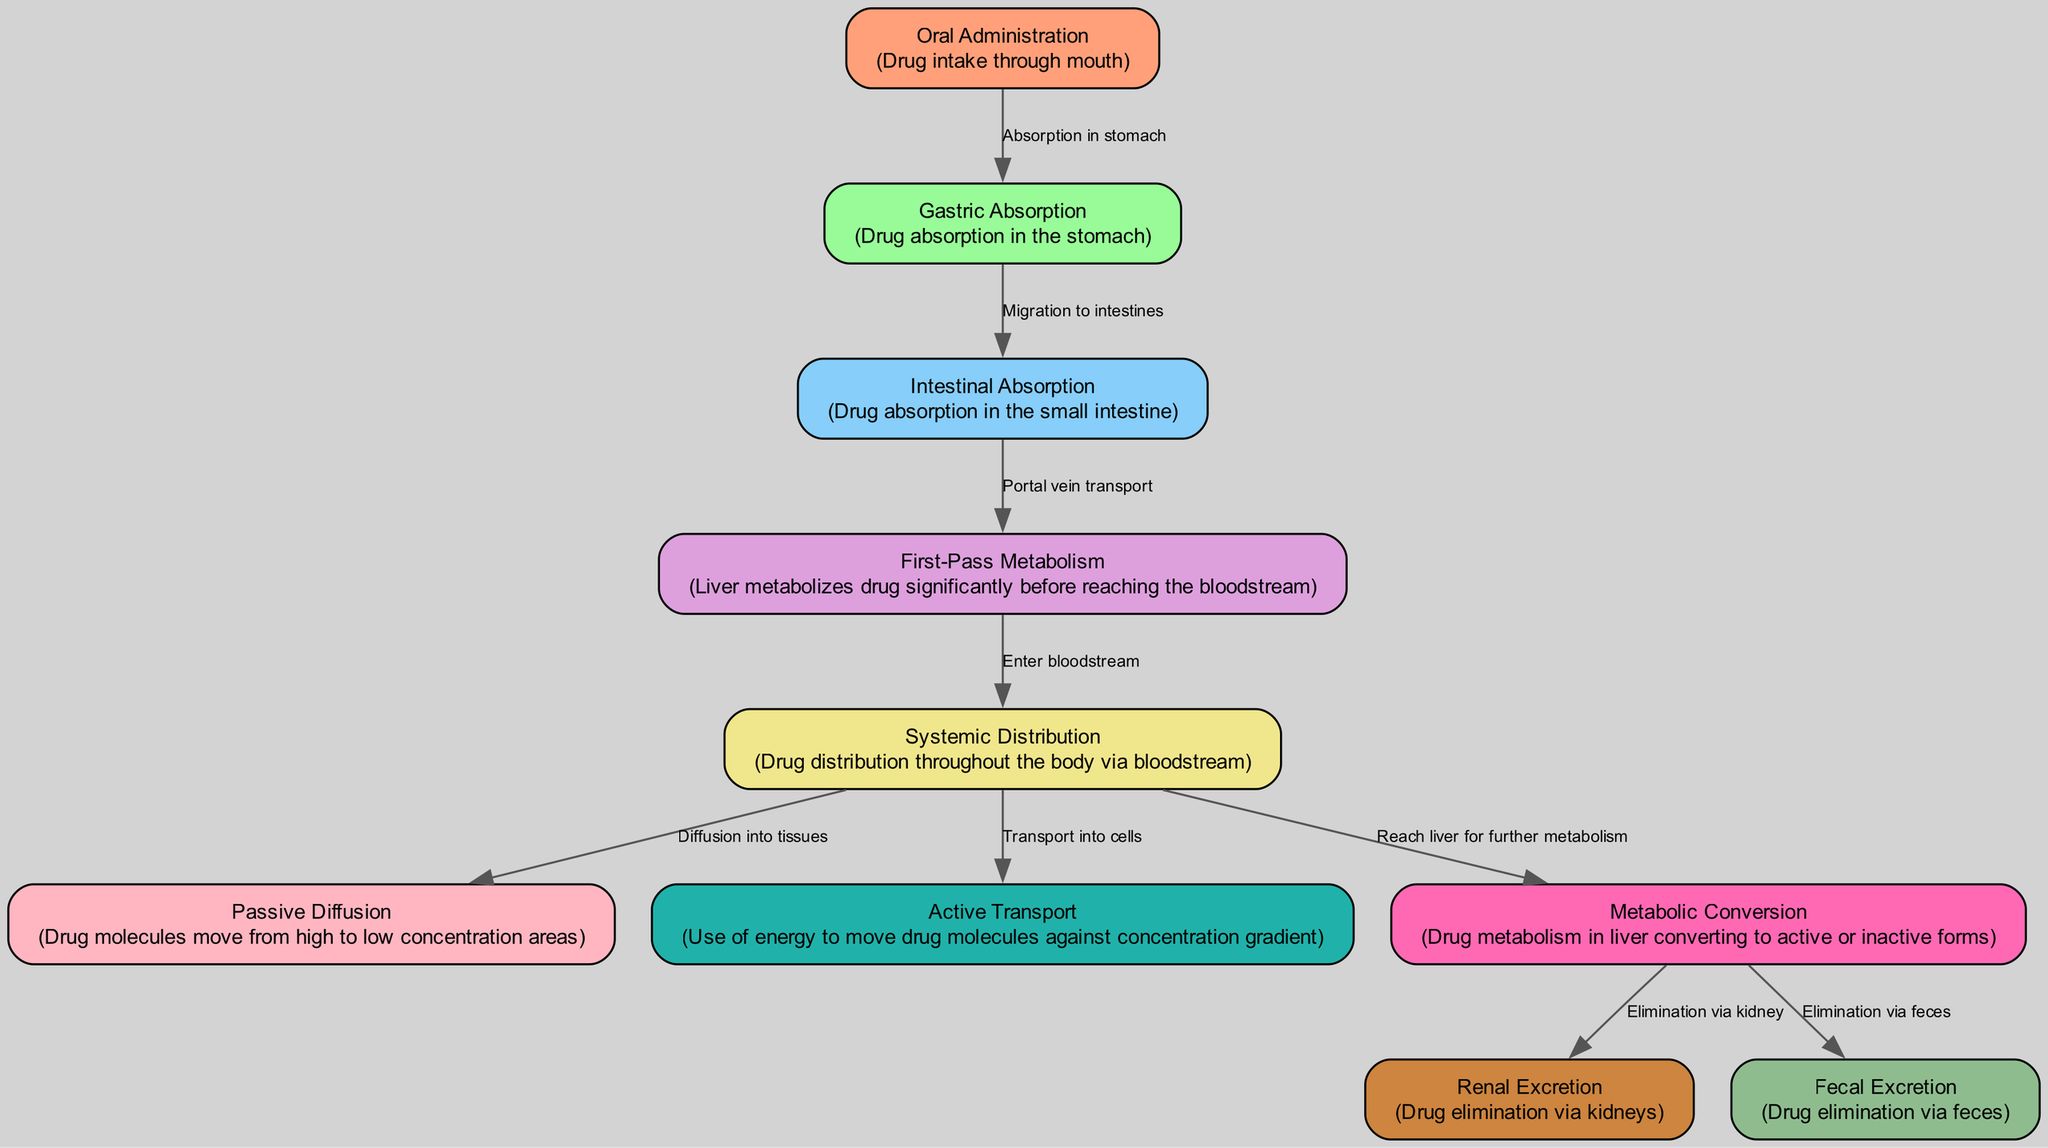What is the first step in the drug absorption pathway? The diagram indicates "Oral Administration" as the starting point, signifying that the drug is taken through the mouth.
Answer: Oral Administration How many nodes are present in the diagram? The diagram contains a total of 10 nodes, representing different stages of drug absorption and metabolism.
Answer: 10 What is the relation between gastric absorption and intestinal absorption? The edge from "Gastric Absorption" to "Intestinal Absorption" indicates migration of the drug to the intestines after absorption in the stomach.
Answer: Migration to intestines Which organ is primarily involved in first-pass metabolism? The diagram specifies the "Liver" as the organ where the first-pass metabolism occurs before the drug enters the bloodstream.
Answer: Liver What process uses energy to move drug molecules? The diagram describes "Active Transport," highlighting that energy is used to move drug molecules against their concentration gradient.
Answer: Active Transport How is the drug eliminated from the body after metabolic conversion? The diagram shows two paths from "Metabolic Conversion": elimination via the kidneys ("Renal Excretion") and via feces ("Fecal Excretion").
Answer: Renal Excretion and Fecal Excretion What mechanism allows drug molecules to enter tissues from the bloodstream? The diagram illustrates "Passive Diffusion" as the process where drug molecules move from areas of high concentration in the bloodstream to low concentration in surrounding tissues.
Answer: Passive Diffusion After gastric absorption, which step follows? According to the diagram, after gastric absorption, the next step is "Intestinal Absorption," where the drug is absorbed in the small intestine.
Answer: Intestinal Absorption How does the drug travel to the bloodstream after intestinal absorption? The diagram indicates that "Portal vein transport" is the mechanism that allows the drug to move from intestinal absorption to first-pass metabolism in the liver.
Answer: Portal vein transport 